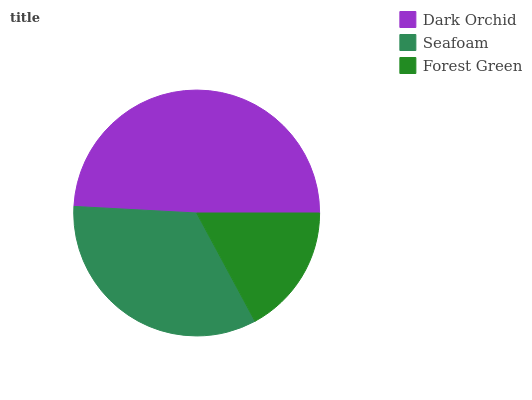Is Forest Green the minimum?
Answer yes or no. Yes. Is Dark Orchid the maximum?
Answer yes or no. Yes. Is Seafoam the minimum?
Answer yes or no. No. Is Seafoam the maximum?
Answer yes or no. No. Is Dark Orchid greater than Seafoam?
Answer yes or no. Yes. Is Seafoam less than Dark Orchid?
Answer yes or no. Yes. Is Seafoam greater than Dark Orchid?
Answer yes or no. No. Is Dark Orchid less than Seafoam?
Answer yes or no. No. Is Seafoam the high median?
Answer yes or no. Yes. Is Seafoam the low median?
Answer yes or no. Yes. Is Forest Green the high median?
Answer yes or no. No. Is Forest Green the low median?
Answer yes or no. No. 